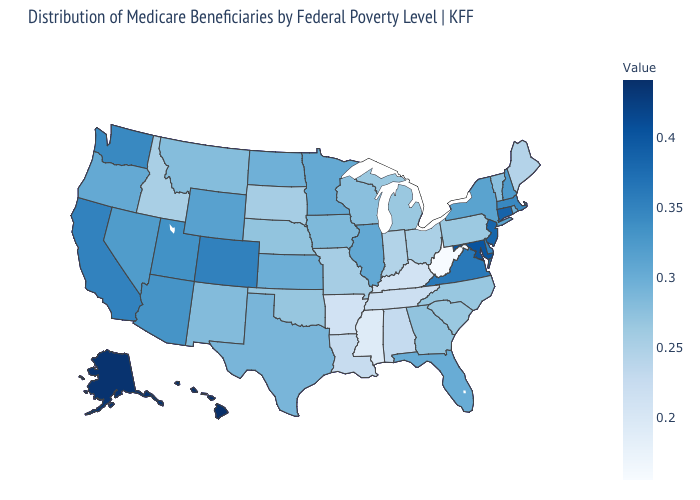Among the states that border Washington , does Idaho have the lowest value?
Be succinct. Yes. Does Illinois have the highest value in the MidWest?
Give a very brief answer. Yes. Which states hav the highest value in the West?
Be succinct. Hawaii. Among the states that border Iowa , does Missouri have the lowest value?
Write a very short answer. Yes. 